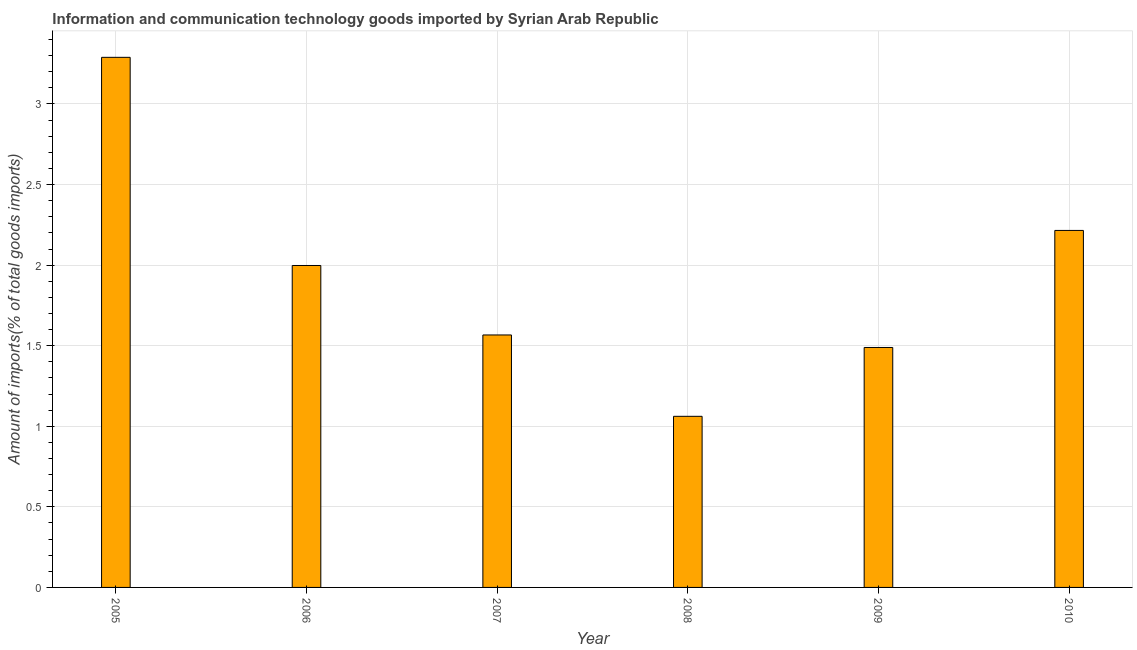Does the graph contain any zero values?
Your answer should be very brief. No. Does the graph contain grids?
Offer a terse response. Yes. What is the title of the graph?
Keep it short and to the point. Information and communication technology goods imported by Syrian Arab Republic. What is the label or title of the Y-axis?
Provide a succinct answer. Amount of imports(% of total goods imports). What is the amount of ict goods imports in 2005?
Offer a terse response. 3.29. Across all years, what is the maximum amount of ict goods imports?
Your response must be concise. 3.29. Across all years, what is the minimum amount of ict goods imports?
Make the answer very short. 1.06. What is the sum of the amount of ict goods imports?
Keep it short and to the point. 11.62. What is the difference between the amount of ict goods imports in 2008 and 2009?
Your response must be concise. -0.43. What is the average amount of ict goods imports per year?
Provide a short and direct response. 1.94. What is the median amount of ict goods imports?
Your answer should be very brief. 1.78. Do a majority of the years between 2006 and 2005 (inclusive) have amount of ict goods imports greater than 1.7 %?
Give a very brief answer. No. What is the ratio of the amount of ict goods imports in 2009 to that in 2010?
Provide a succinct answer. 0.67. Is the amount of ict goods imports in 2008 less than that in 2010?
Your answer should be compact. Yes. Is the difference between the amount of ict goods imports in 2006 and 2009 greater than the difference between any two years?
Give a very brief answer. No. What is the difference between the highest and the second highest amount of ict goods imports?
Keep it short and to the point. 1.07. What is the difference between the highest and the lowest amount of ict goods imports?
Keep it short and to the point. 2.23. How many years are there in the graph?
Provide a short and direct response. 6. What is the difference between two consecutive major ticks on the Y-axis?
Offer a terse response. 0.5. What is the Amount of imports(% of total goods imports) in 2005?
Make the answer very short. 3.29. What is the Amount of imports(% of total goods imports) in 2006?
Keep it short and to the point. 2. What is the Amount of imports(% of total goods imports) in 2007?
Give a very brief answer. 1.57. What is the Amount of imports(% of total goods imports) in 2008?
Provide a short and direct response. 1.06. What is the Amount of imports(% of total goods imports) of 2009?
Keep it short and to the point. 1.49. What is the Amount of imports(% of total goods imports) of 2010?
Provide a short and direct response. 2.22. What is the difference between the Amount of imports(% of total goods imports) in 2005 and 2006?
Make the answer very short. 1.29. What is the difference between the Amount of imports(% of total goods imports) in 2005 and 2007?
Provide a succinct answer. 1.72. What is the difference between the Amount of imports(% of total goods imports) in 2005 and 2008?
Keep it short and to the point. 2.23. What is the difference between the Amount of imports(% of total goods imports) in 2005 and 2009?
Provide a succinct answer. 1.8. What is the difference between the Amount of imports(% of total goods imports) in 2005 and 2010?
Your response must be concise. 1.07. What is the difference between the Amount of imports(% of total goods imports) in 2006 and 2007?
Offer a terse response. 0.43. What is the difference between the Amount of imports(% of total goods imports) in 2006 and 2008?
Ensure brevity in your answer.  0.94. What is the difference between the Amount of imports(% of total goods imports) in 2006 and 2009?
Keep it short and to the point. 0.51. What is the difference between the Amount of imports(% of total goods imports) in 2006 and 2010?
Offer a terse response. -0.22. What is the difference between the Amount of imports(% of total goods imports) in 2007 and 2008?
Your answer should be very brief. 0.5. What is the difference between the Amount of imports(% of total goods imports) in 2007 and 2009?
Your answer should be very brief. 0.08. What is the difference between the Amount of imports(% of total goods imports) in 2007 and 2010?
Provide a succinct answer. -0.65. What is the difference between the Amount of imports(% of total goods imports) in 2008 and 2009?
Your answer should be very brief. -0.43. What is the difference between the Amount of imports(% of total goods imports) in 2008 and 2010?
Make the answer very short. -1.15. What is the difference between the Amount of imports(% of total goods imports) in 2009 and 2010?
Offer a very short reply. -0.73. What is the ratio of the Amount of imports(% of total goods imports) in 2005 to that in 2006?
Give a very brief answer. 1.65. What is the ratio of the Amount of imports(% of total goods imports) in 2005 to that in 2007?
Your answer should be very brief. 2.1. What is the ratio of the Amount of imports(% of total goods imports) in 2005 to that in 2008?
Your response must be concise. 3.1. What is the ratio of the Amount of imports(% of total goods imports) in 2005 to that in 2009?
Offer a very short reply. 2.21. What is the ratio of the Amount of imports(% of total goods imports) in 2005 to that in 2010?
Your answer should be very brief. 1.49. What is the ratio of the Amount of imports(% of total goods imports) in 2006 to that in 2007?
Offer a terse response. 1.27. What is the ratio of the Amount of imports(% of total goods imports) in 2006 to that in 2008?
Give a very brief answer. 1.88. What is the ratio of the Amount of imports(% of total goods imports) in 2006 to that in 2009?
Keep it short and to the point. 1.34. What is the ratio of the Amount of imports(% of total goods imports) in 2006 to that in 2010?
Make the answer very short. 0.9. What is the ratio of the Amount of imports(% of total goods imports) in 2007 to that in 2008?
Ensure brevity in your answer.  1.48. What is the ratio of the Amount of imports(% of total goods imports) in 2007 to that in 2009?
Offer a very short reply. 1.05. What is the ratio of the Amount of imports(% of total goods imports) in 2007 to that in 2010?
Your answer should be very brief. 0.71. What is the ratio of the Amount of imports(% of total goods imports) in 2008 to that in 2009?
Ensure brevity in your answer.  0.71. What is the ratio of the Amount of imports(% of total goods imports) in 2008 to that in 2010?
Offer a very short reply. 0.48. What is the ratio of the Amount of imports(% of total goods imports) in 2009 to that in 2010?
Give a very brief answer. 0.67. 